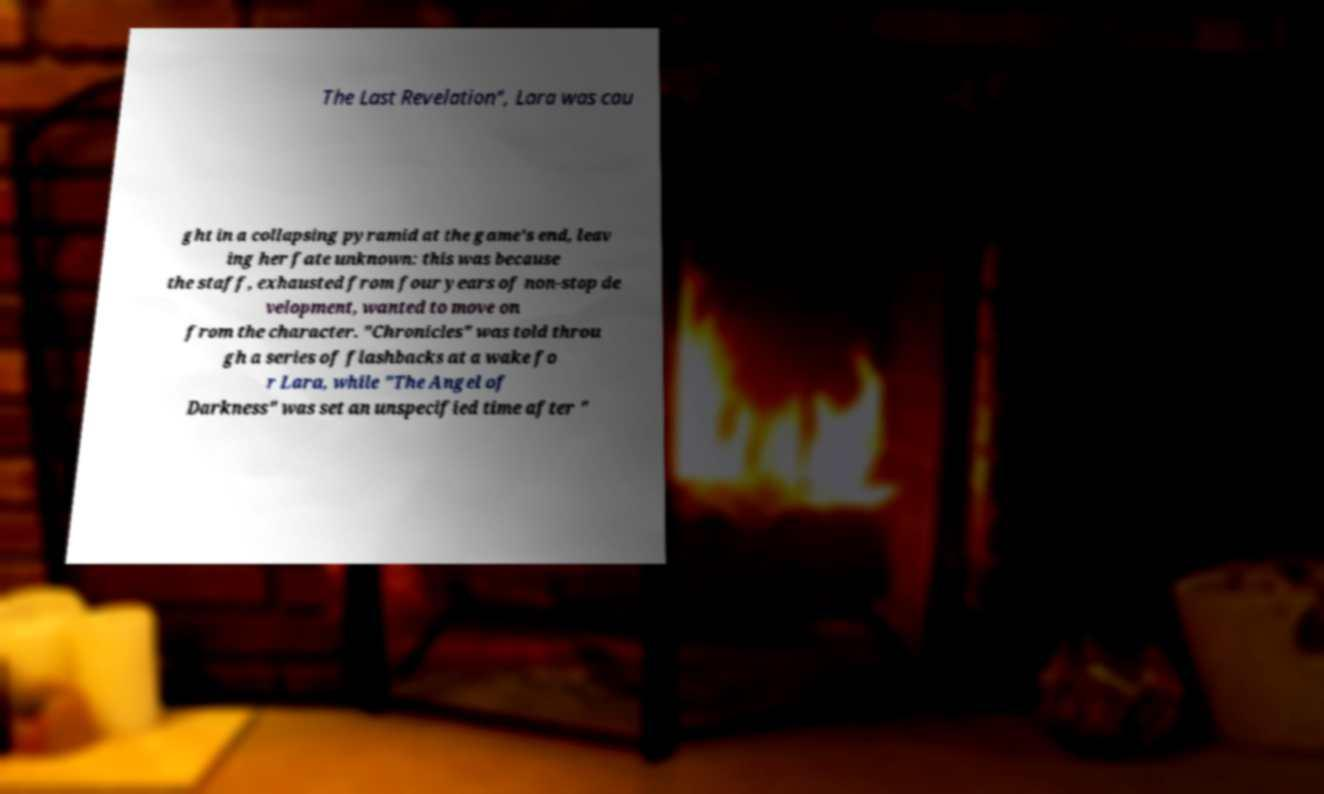Please identify and transcribe the text found in this image. The Last Revelation", Lara was cau ght in a collapsing pyramid at the game's end, leav ing her fate unknown: this was because the staff, exhausted from four years of non-stop de velopment, wanted to move on from the character. "Chronicles" was told throu gh a series of flashbacks at a wake fo r Lara, while "The Angel of Darkness" was set an unspecified time after " 